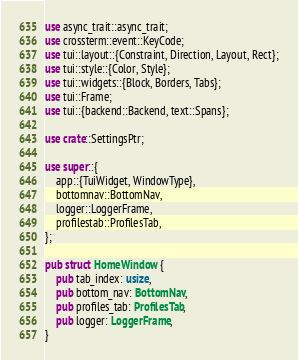Convert code to text. <code><loc_0><loc_0><loc_500><loc_500><_Rust_>use async_trait::async_trait;
use crossterm::event::KeyCode;
use tui::layout::{Constraint, Direction, Layout, Rect};
use tui::style::{Color, Style};
use tui::widgets::{Block, Borders, Tabs};
use tui::Frame;
use tui::{backend::Backend, text::Spans};

use crate::SettingsPtr;

use super::{
    app::{TuiWidget, WindowType},
    bottomnav::BottomNav,
    logger::LoggerFrame,
    profilestab::ProfilesTab,
};

pub struct HomeWindow {
    pub tab_index: usize,
    pub bottom_nav: BottomNav,
    pub profiles_tab: ProfilesTab,
    pub logger: LoggerFrame,
}
</code> 